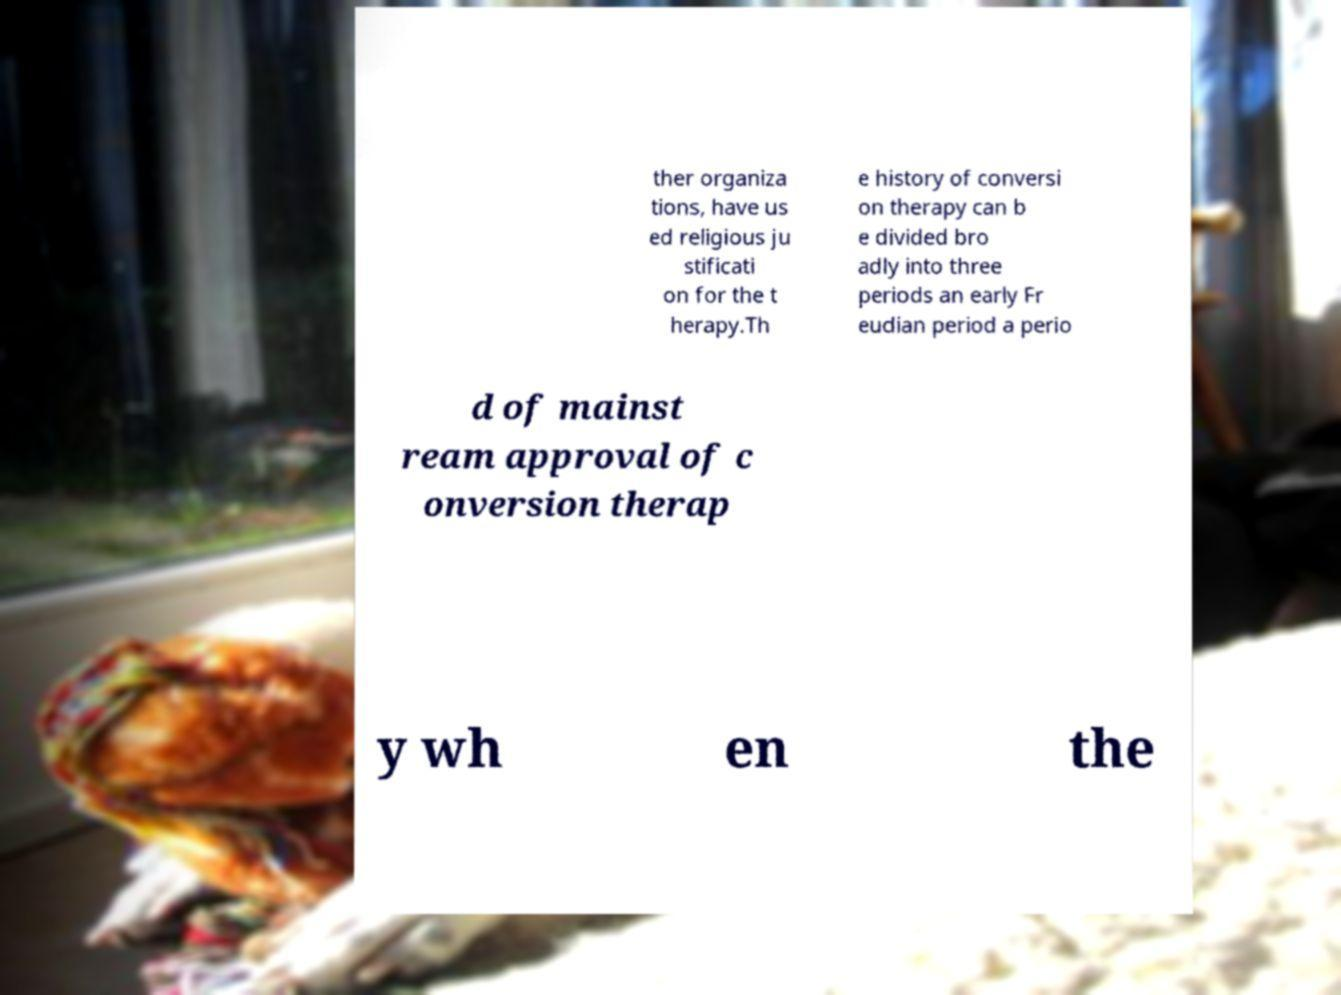Could you assist in decoding the text presented in this image and type it out clearly? ther organiza tions, have us ed religious ju stificati on for the t herapy.Th e history of conversi on therapy can b e divided bro adly into three periods an early Fr eudian period a perio d of mainst ream approval of c onversion therap y wh en the 